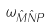<formula> <loc_0><loc_0><loc_500><loc_500>\omega _ { \hat { M } \hat { N } P }</formula> 